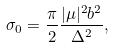Convert formula to latex. <formula><loc_0><loc_0><loc_500><loc_500>\sigma _ { 0 } = \frac { \pi } { 2 } \frac { | \mu | ^ { 2 } b ^ { 2 } } { \Delta ^ { 2 } } ,</formula> 